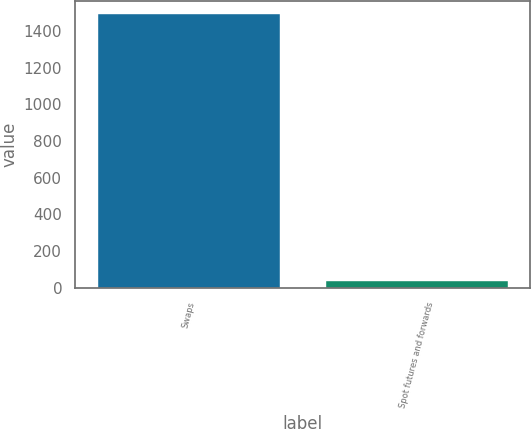Convert chart. <chart><loc_0><loc_0><loc_500><loc_500><bar_chart><fcel>Swaps<fcel>Spot futures and forwards<nl><fcel>1490.7<fcel>37.2<nl></chart> 